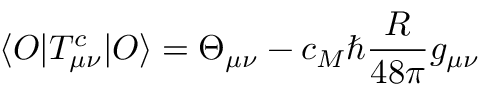<formula> <loc_0><loc_0><loc_500><loc_500>\langle O | T _ { \mu \nu } ^ { c } | O \rangle = \Theta _ { \mu \nu } - c _ { M } \hbar { \frac { R } { 4 8 \pi } } g _ { \mu \nu }</formula> 